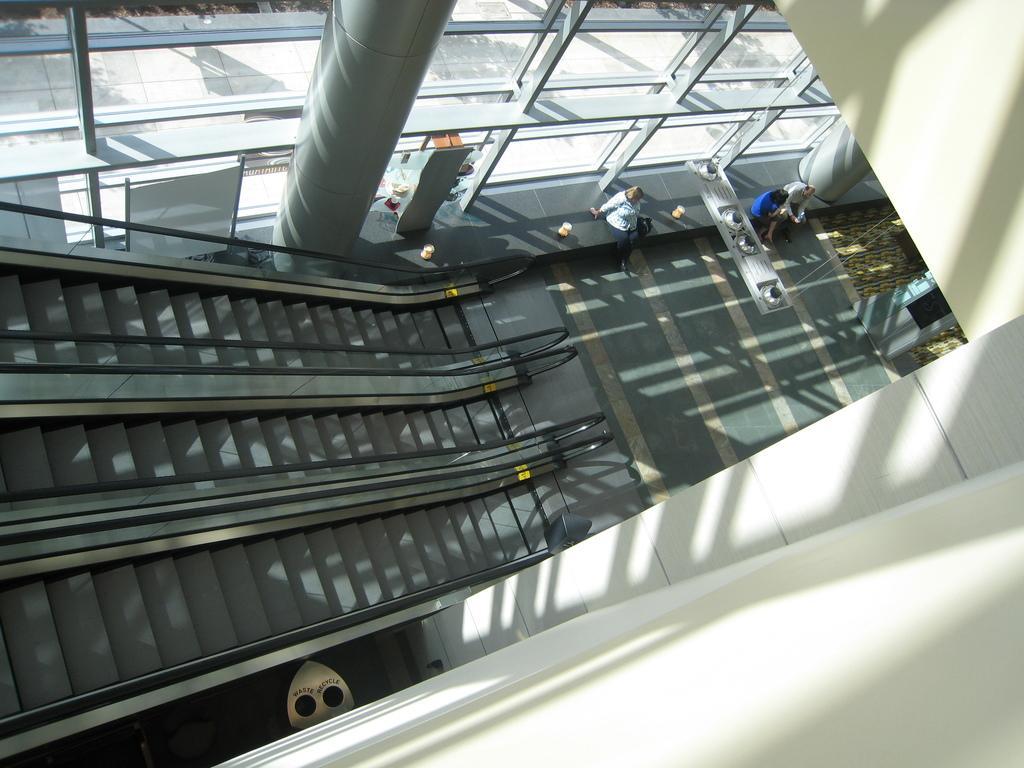Describe this image in one or two sentences. In this image we can see escalators. On the right side of the image we can see group of persons. At the bottom of the image there is wall. At the top we can see pillar, door and glass windows. 